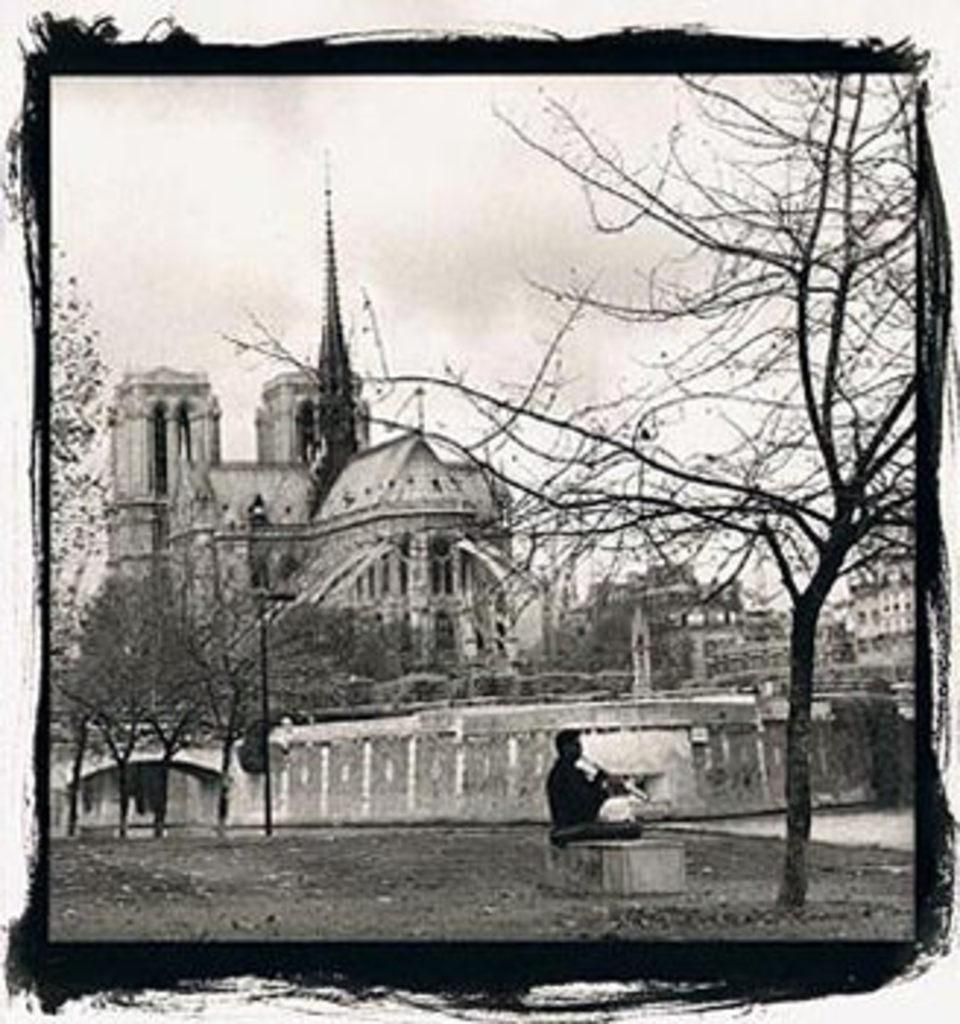What is the person in the image doing? The person is sitting on a path in the image. What can be seen in the distance behind the person? There are buildings and trees in the background of the image. What type of tub is visible in the image? There is no tub present in the image. 